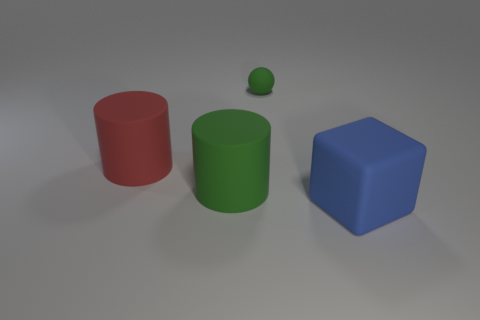There is a big green rubber thing; what shape is it?
Your answer should be very brief. Cylinder. There is a large object that is left of the green rubber cylinder; does it have the same shape as the small green object?
Your answer should be very brief. No. Is the number of large matte blocks that are behind the blue thing greater than the number of tiny green spheres behind the red thing?
Provide a succinct answer. No. What number of other objects are the same size as the blue rubber thing?
Keep it short and to the point. 2. There is a big blue thing; is its shape the same as the green matte thing that is right of the green cylinder?
Provide a succinct answer. No. What number of metallic objects are either big blocks or cylinders?
Offer a very short reply. 0. Are there any things of the same color as the small matte ball?
Keep it short and to the point. Yes. Are any purple rubber cubes visible?
Give a very brief answer. No. Do the big green object and the large red object have the same shape?
Offer a terse response. Yes. What number of large things are either rubber objects or spheres?
Give a very brief answer. 3. 